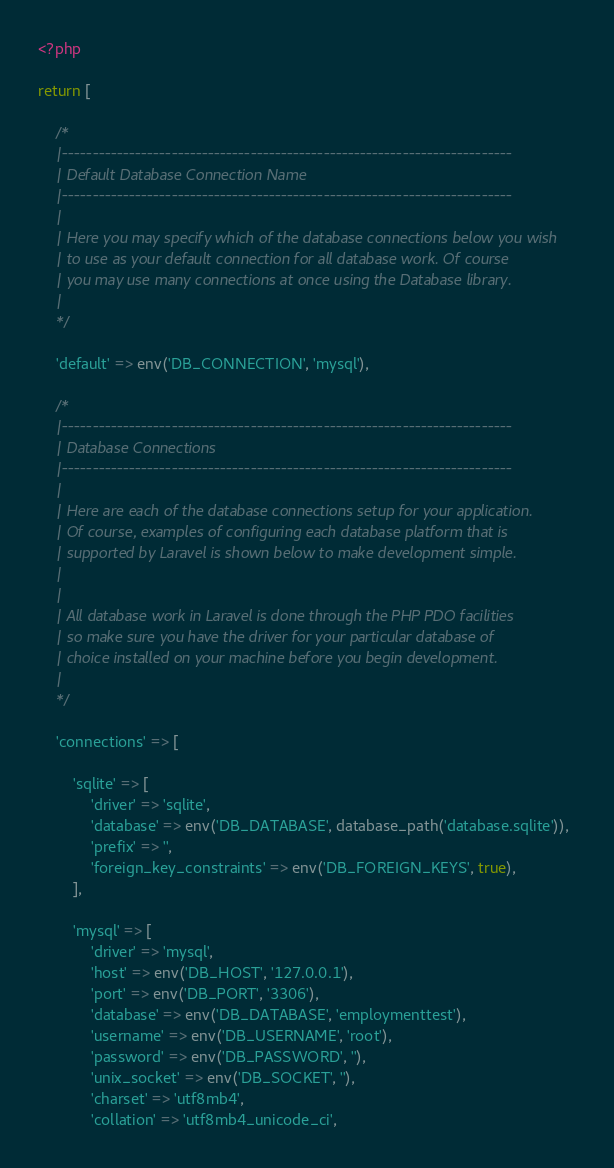Convert code to text. <code><loc_0><loc_0><loc_500><loc_500><_PHP_><?php

return [

    /*
    |--------------------------------------------------------------------------
    | Default Database Connection Name
    |--------------------------------------------------------------------------
    |
    | Here you may specify which of the database connections below you wish
    | to use as your default connection for all database work. Of course
    | you may use many connections at once using the Database library.
    |
    */

    'default' => env('DB_CONNECTION', 'mysql'),

    /*
    |--------------------------------------------------------------------------
    | Database Connections
    |--------------------------------------------------------------------------
    |
    | Here are each of the database connections setup for your application.
    | Of course, examples of configuring each database platform that is
    | supported by Laravel is shown below to make development simple.
    |
    |
    | All database work in Laravel is done through the PHP PDO facilities
    | so make sure you have the driver for your particular database of
    | choice installed on your machine before you begin development.
    |
    */

    'connections' => [

        'sqlite' => [
            'driver' => 'sqlite',
            'database' => env('DB_DATABASE', database_path('database.sqlite')),
            'prefix' => '',
            'foreign_key_constraints' => env('DB_FOREIGN_KEYS', true),
        ],

        'mysql' => [
            'driver' => 'mysql',
            'host' => env('DB_HOST', '127.0.0.1'),
            'port' => env('DB_PORT', '3306'),
            'database' => env('DB_DATABASE', 'employmenttest'),
            'username' => env('DB_USERNAME', 'root'),
            'password' => env('DB_PASSWORD', ''),
            'unix_socket' => env('DB_SOCKET', ''),
            'charset' => 'utf8mb4',
            'collation' => 'utf8mb4_unicode_ci',</code> 